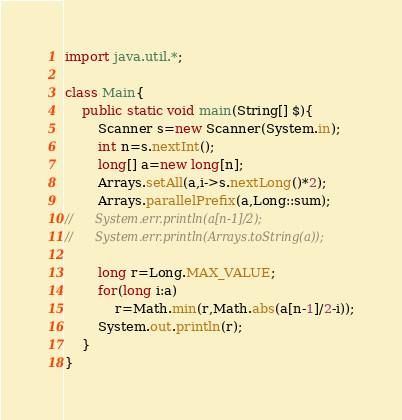<code> <loc_0><loc_0><loc_500><loc_500><_Java_>import java.util.*;

class Main{
	public static void main(String[] $){
		Scanner s=new Scanner(System.in);
		int n=s.nextInt();
		long[] a=new long[n];
		Arrays.setAll(a,i->s.nextLong()*2);
		Arrays.parallelPrefix(a,Long::sum);
//		System.err.println(a[n-1]/2);
//		System.err.println(Arrays.toString(a));

		long r=Long.MAX_VALUE;
		for(long i:a)
			r=Math.min(r,Math.abs(a[n-1]/2-i));
		System.out.println(r);
	}
}
</code> 